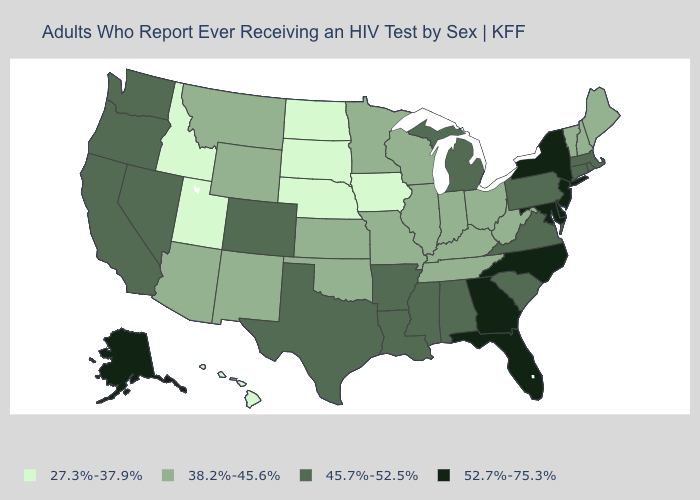Among the states that border Massachusetts , which have the lowest value?
Write a very short answer. New Hampshire, Vermont. Does Washington have a lower value than Montana?
Be succinct. No. How many symbols are there in the legend?
Quick response, please. 4. Does Montana have a lower value than Utah?
Keep it brief. No. Which states hav the highest value in the West?
Quick response, please. Alaska. What is the value of Pennsylvania?
Answer briefly. 45.7%-52.5%. Among the states that border Pennsylvania , does West Virginia have the highest value?
Give a very brief answer. No. What is the lowest value in the USA?
Write a very short answer. 27.3%-37.9%. Is the legend a continuous bar?
Be succinct. No. Name the states that have a value in the range 38.2%-45.6%?
Keep it brief. Arizona, Illinois, Indiana, Kansas, Kentucky, Maine, Minnesota, Missouri, Montana, New Hampshire, New Mexico, Ohio, Oklahoma, Tennessee, Vermont, West Virginia, Wisconsin, Wyoming. What is the value of Rhode Island?
Concise answer only. 45.7%-52.5%. Name the states that have a value in the range 38.2%-45.6%?
Quick response, please. Arizona, Illinois, Indiana, Kansas, Kentucky, Maine, Minnesota, Missouri, Montana, New Hampshire, New Mexico, Ohio, Oklahoma, Tennessee, Vermont, West Virginia, Wisconsin, Wyoming. Which states have the lowest value in the USA?
Write a very short answer. Hawaii, Idaho, Iowa, Nebraska, North Dakota, South Dakota, Utah. What is the lowest value in states that border Arizona?
Be succinct. 27.3%-37.9%. What is the lowest value in states that border Missouri?
Write a very short answer. 27.3%-37.9%. 